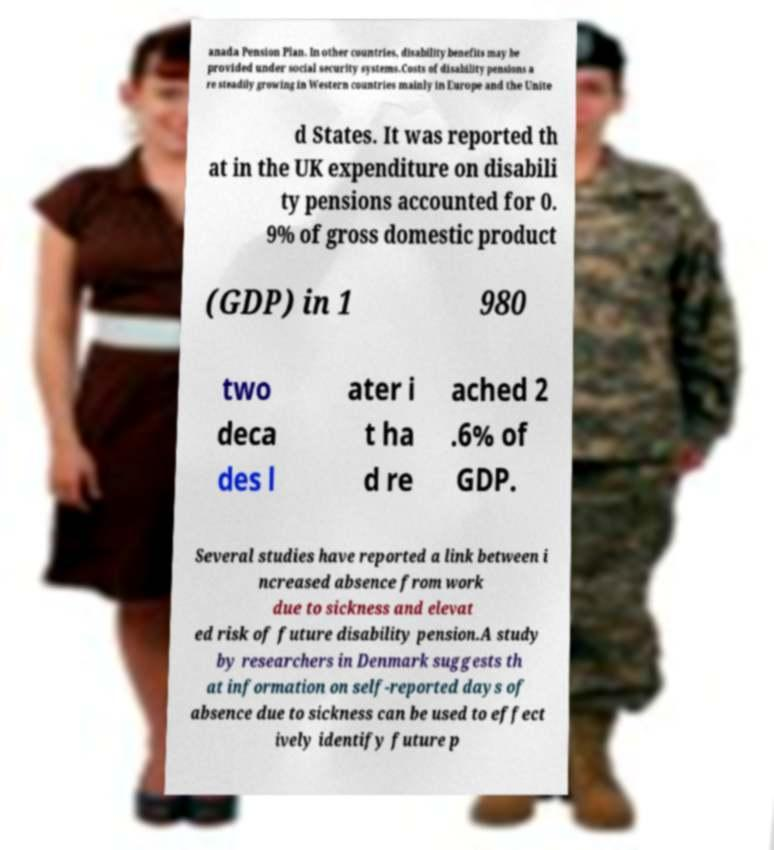What messages or text are displayed in this image? I need them in a readable, typed format. anada Pension Plan. In other countries, disability benefits may be provided under social security systems.Costs of disability pensions a re steadily growing in Western countries mainly in Europe and the Unite d States. It was reported th at in the UK expenditure on disabili ty pensions accounted for 0. 9% of gross domestic product (GDP) in 1 980 two deca des l ater i t ha d re ached 2 .6% of GDP. Several studies have reported a link between i ncreased absence from work due to sickness and elevat ed risk of future disability pension.A study by researchers in Denmark suggests th at information on self-reported days of absence due to sickness can be used to effect ively identify future p 